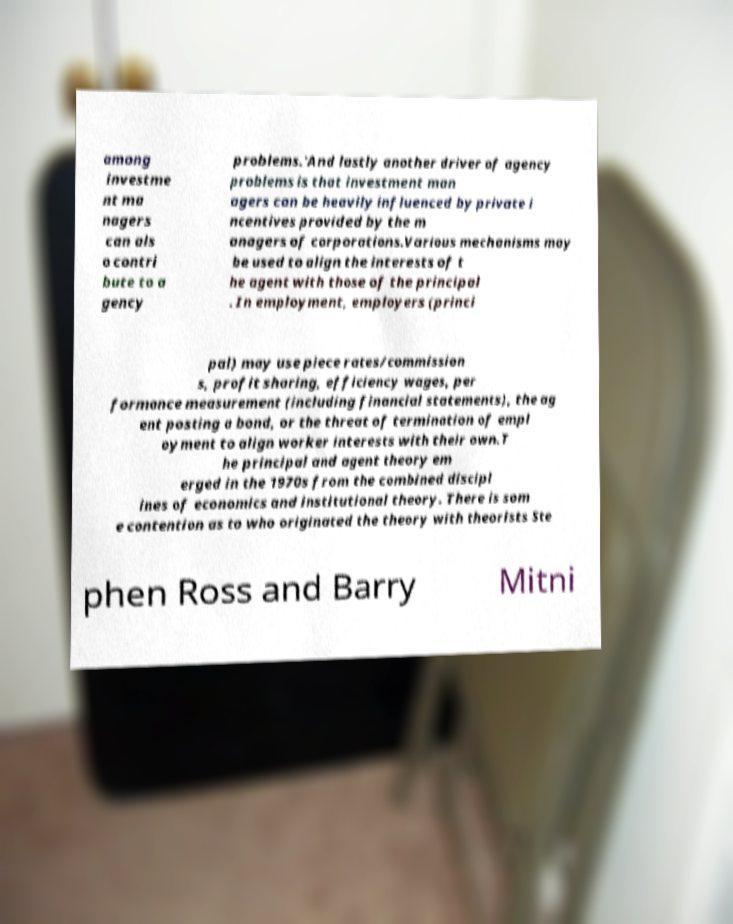I need the written content from this picture converted into text. Can you do that? among investme nt ma nagers can als o contri bute to a gency problems.'And lastly another driver of agency problems is that investment man agers can be heavily influenced by private i ncentives provided by the m anagers of corporations.Various mechanisms may be used to align the interests of t he agent with those of the principal . In employment, employers (princi pal) may use piece rates/commission s, profit sharing, efficiency wages, per formance measurement (including financial statements), the ag ent posting a bond, or the threat of termination of empl oyment to align worker interests with their own.T he principal and agent theory em erged in the 1970s from the combined discipl ines of economics and institutional theory. There is som e contention as to who originated the theory with theorists Ste phen Ross and Barry Mitni 